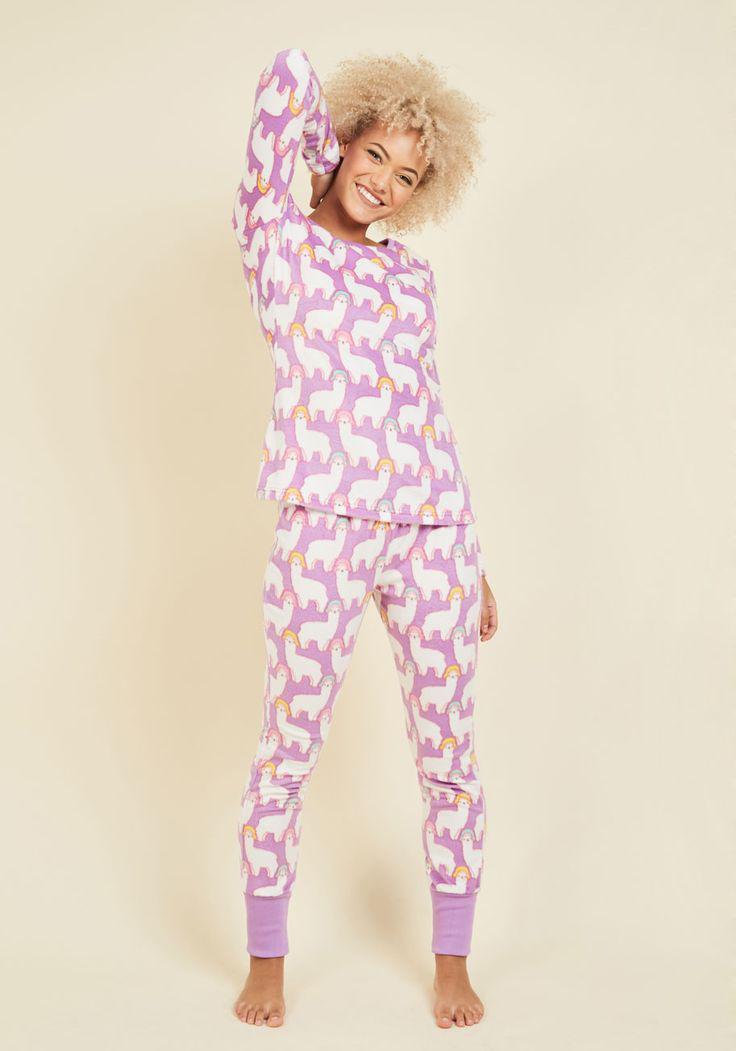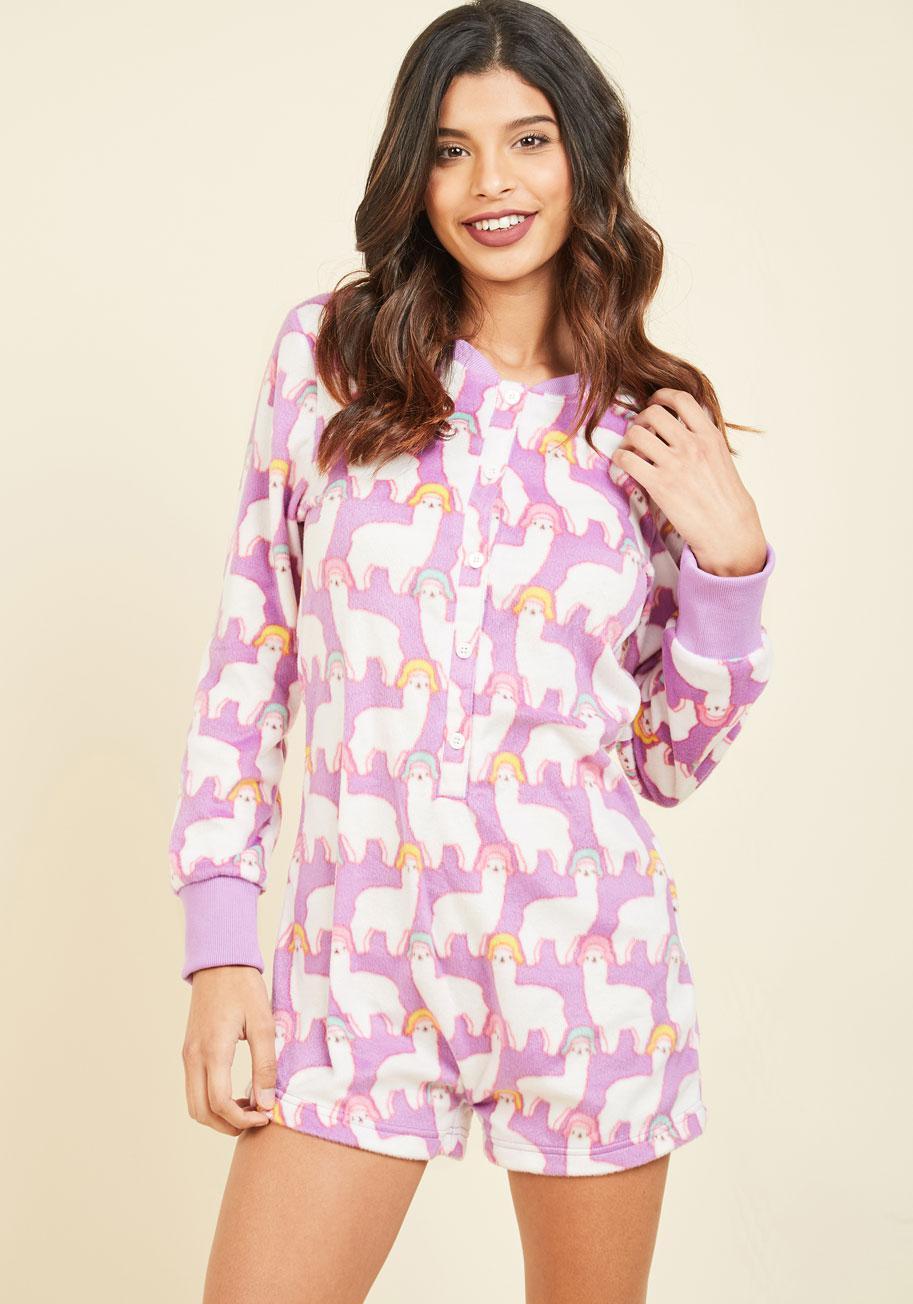The first image is the image on the left, the second image is the image on the right. Considering the images on both sides, is "An adult woman in one image is wearing a printed pajama set with tight fitting pants that have wide, solid-color cuffs at the ankles." valid? Answer yes or no. Yes. The first image is the image on the left, the second image is the image on the right. Examine the images to the left and right. Is the description "The woman in the image on the left has her feet close together." accurate? Answer yes or no. No. 